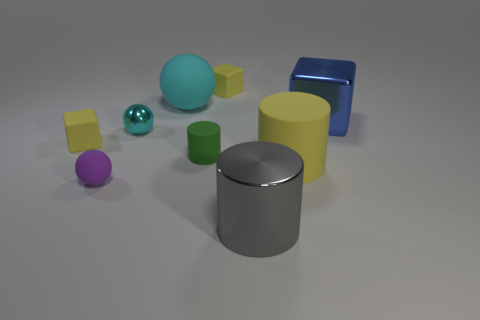Subtract all small yellow matte cubes. How many cubes are left? 1 Add 1 big green matte cylinders. How many objects exist? 10 Subtract all blue cubes. How many cubes are left? 2 Subtract all cubes. How many objects are left? 6 Subtract 0 purple cylinders. How many objects are left? 9 Subtract 1 balls. How many balls are left? 2 Subtract all red cylinders. Subtract all cyan blocks. How many cylinders are left? 3 Subtract all blue spheres. How many blue cubes are left? 1 Subtract all small purple cylinders. Subtract all small purple things. How many objects are left? 8 Add 8 yellow cylinders. How many yellow cylinders are left? 9 